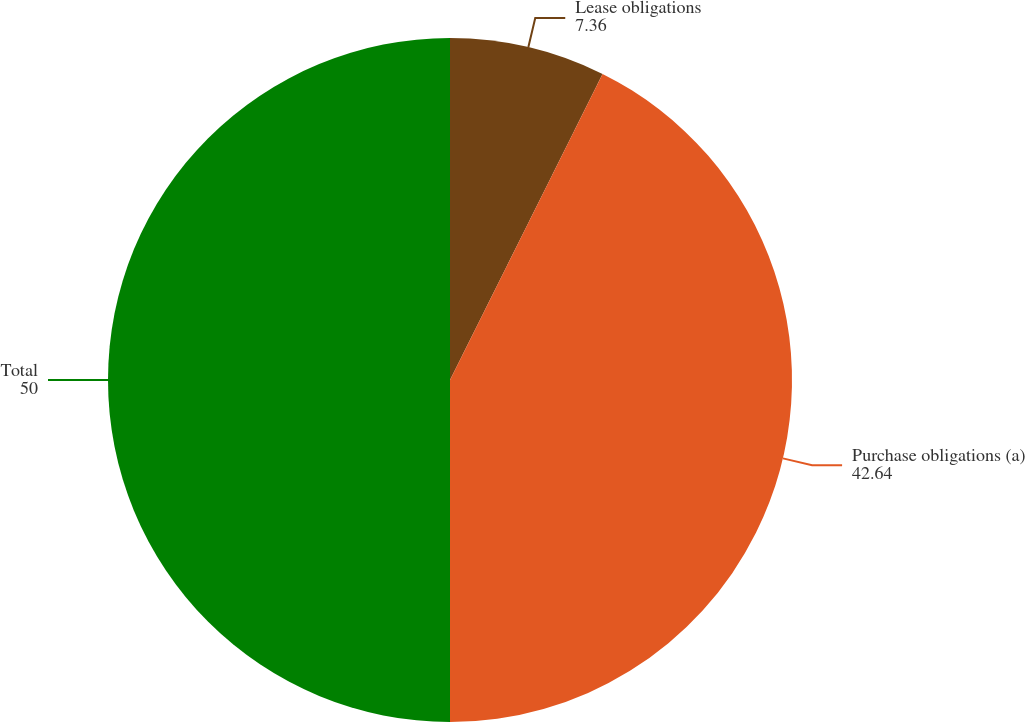Convert chart to OTSL. <chart><loc_0><loc_0><loc_500><loc_500><pie_chart><fcel>Lease obligations<fcel>Purchase obligations (a)<fcel>Total<nl><fcel>7.36%<fcel>42.64%<fcel>50.0%<nl></chart> 